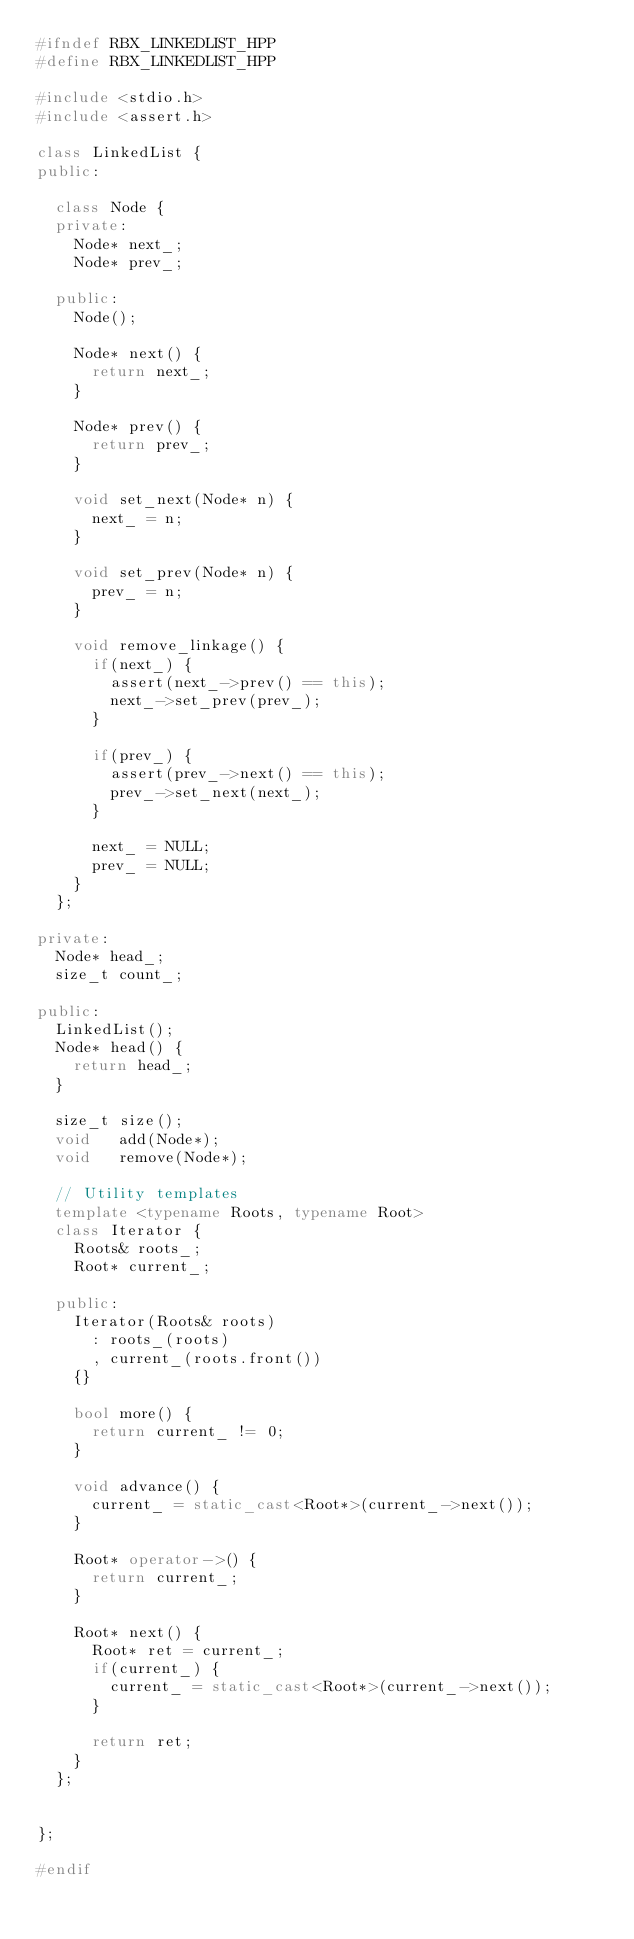Convert code to text. <code><loc_0><loc_0><loc_500><loc_500><_C++_>#ifndef RBX_LINKEDLIST_HPP
#define RBX_LINKEDLIST_HPP

#include <stdio.h>
#include <assert.h>

class LinkedList {
public:

  class Node {
  private:
    Node* next_;
    Node* prev_;

  public:
    Node();

    Node* next() {
      return next_;
    }

    Node* prev() {
      return prev_;
    }

    void set_next(Node* n) {
      next_ = n;
    }

    void set_prev(Node* n) {
      prev_ = n;
    }

    void remove_linkage() {
      if(next_) {
        assert(next_->prev() == this);
        next_->set_prev(prev_);
      }

      if(prev_) {
        assert(prev_->next() == this);
        prev_->set_next(next_);
      }

      next_ = NULL;
      prev_ = NULL;
    }
  };

private:
  Node* head_;
  size_t count_;

public:
  LinkedList();
  Node* head() {
    return head_;
  }

  size_t size();
  void   add(Node*);
  void   remove(Node*);

  // Utility templates
  template <typename Roots, typename Root>
  class Iterator {
    Roots& roots_;
    Root* current_;

  public:
    Iterator(Roots& roots)
      : roots_(roots)
      , current_(roots.front())
    {}

    bool more() {
      return current_ != 0;
    }

    void advance() {
      current_ = static_cast<Root*>(current_->next());
    }

    Root* operator->() {
      return current_;
    }

    Root* next() {
      Root* ret = current_;
      if(current_) {
        current_ = static_cast<Root*>(current_->next());
      }

      return ret;
    }
  };


};

#endif
</code> 